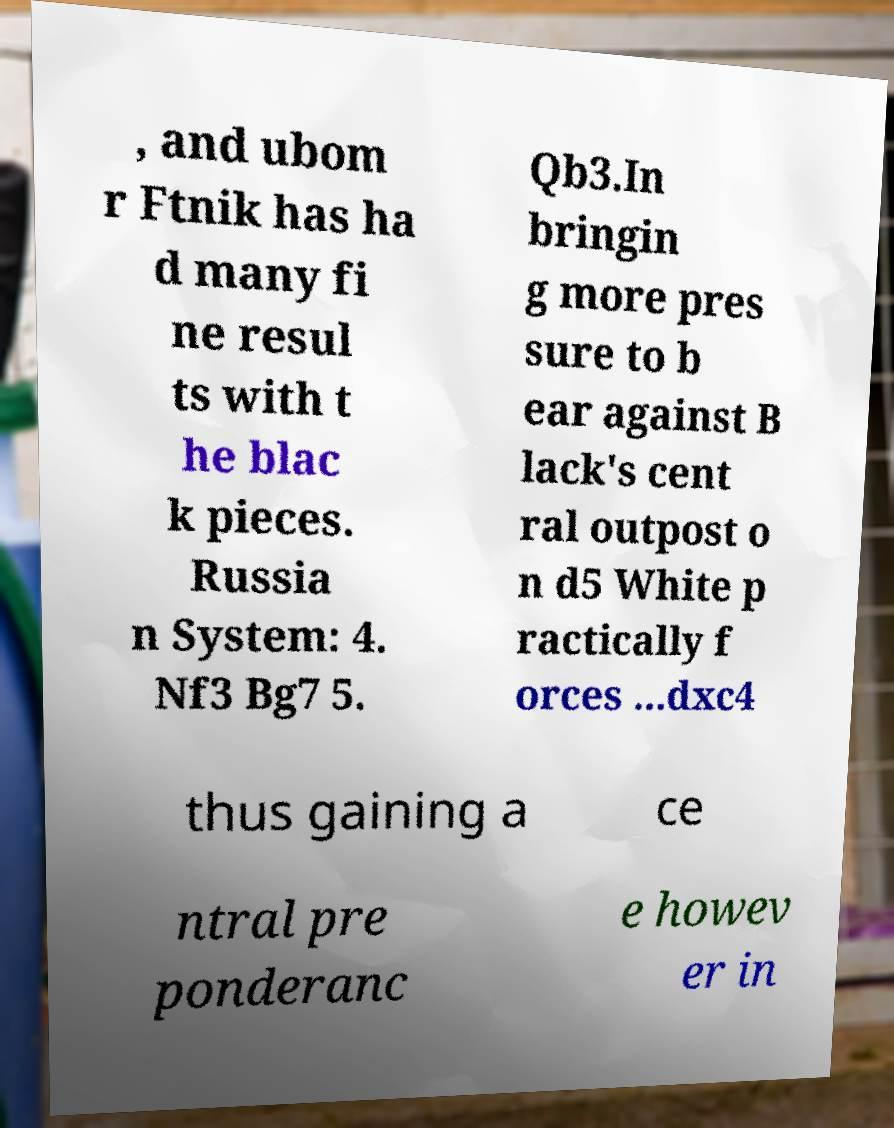I need the written content from this picture converted into text. Can you do that? , and ubom r Ftnik has ha d many fi ne resul ts with t he blac k pieces. Russia n System: 4. Nf3 Bg7 5. Qb3.In bringin g more pres sure to b ear against B lack's cent ral outpost o n d5 White p ractically f orces ...dxc4 thus gaining a ce ntral pre ponderanc e howev er in 